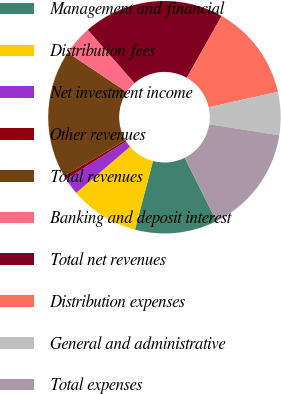Convert chart. <chart><loc_0><loc_0><loc_500><loc_500><pie_chart><fcel>Management and financial<fcel>Distribution fees<fcel>Net investment income<fcel>Other revenues<fcel>Total revenues<fcel>Banking and deposit interest<fcel>Total net revenues<fcel>Distribution expenses<fcel>General and administrative<fcel>Total expenses<nl><fcel>11.47%<fcel>9.64%<fcel>2.33%<fcel>0.51%<fcel>17.82%<fcel>4.16%<fcel>19.65%<fcel>13.3%<fcel>5.99%<fcel>15.13%<nl></chart> 